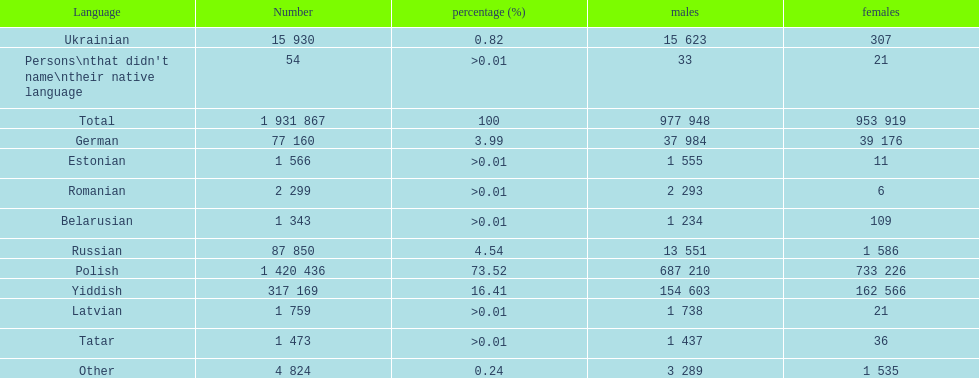Number of male russian speakers 13 551. 